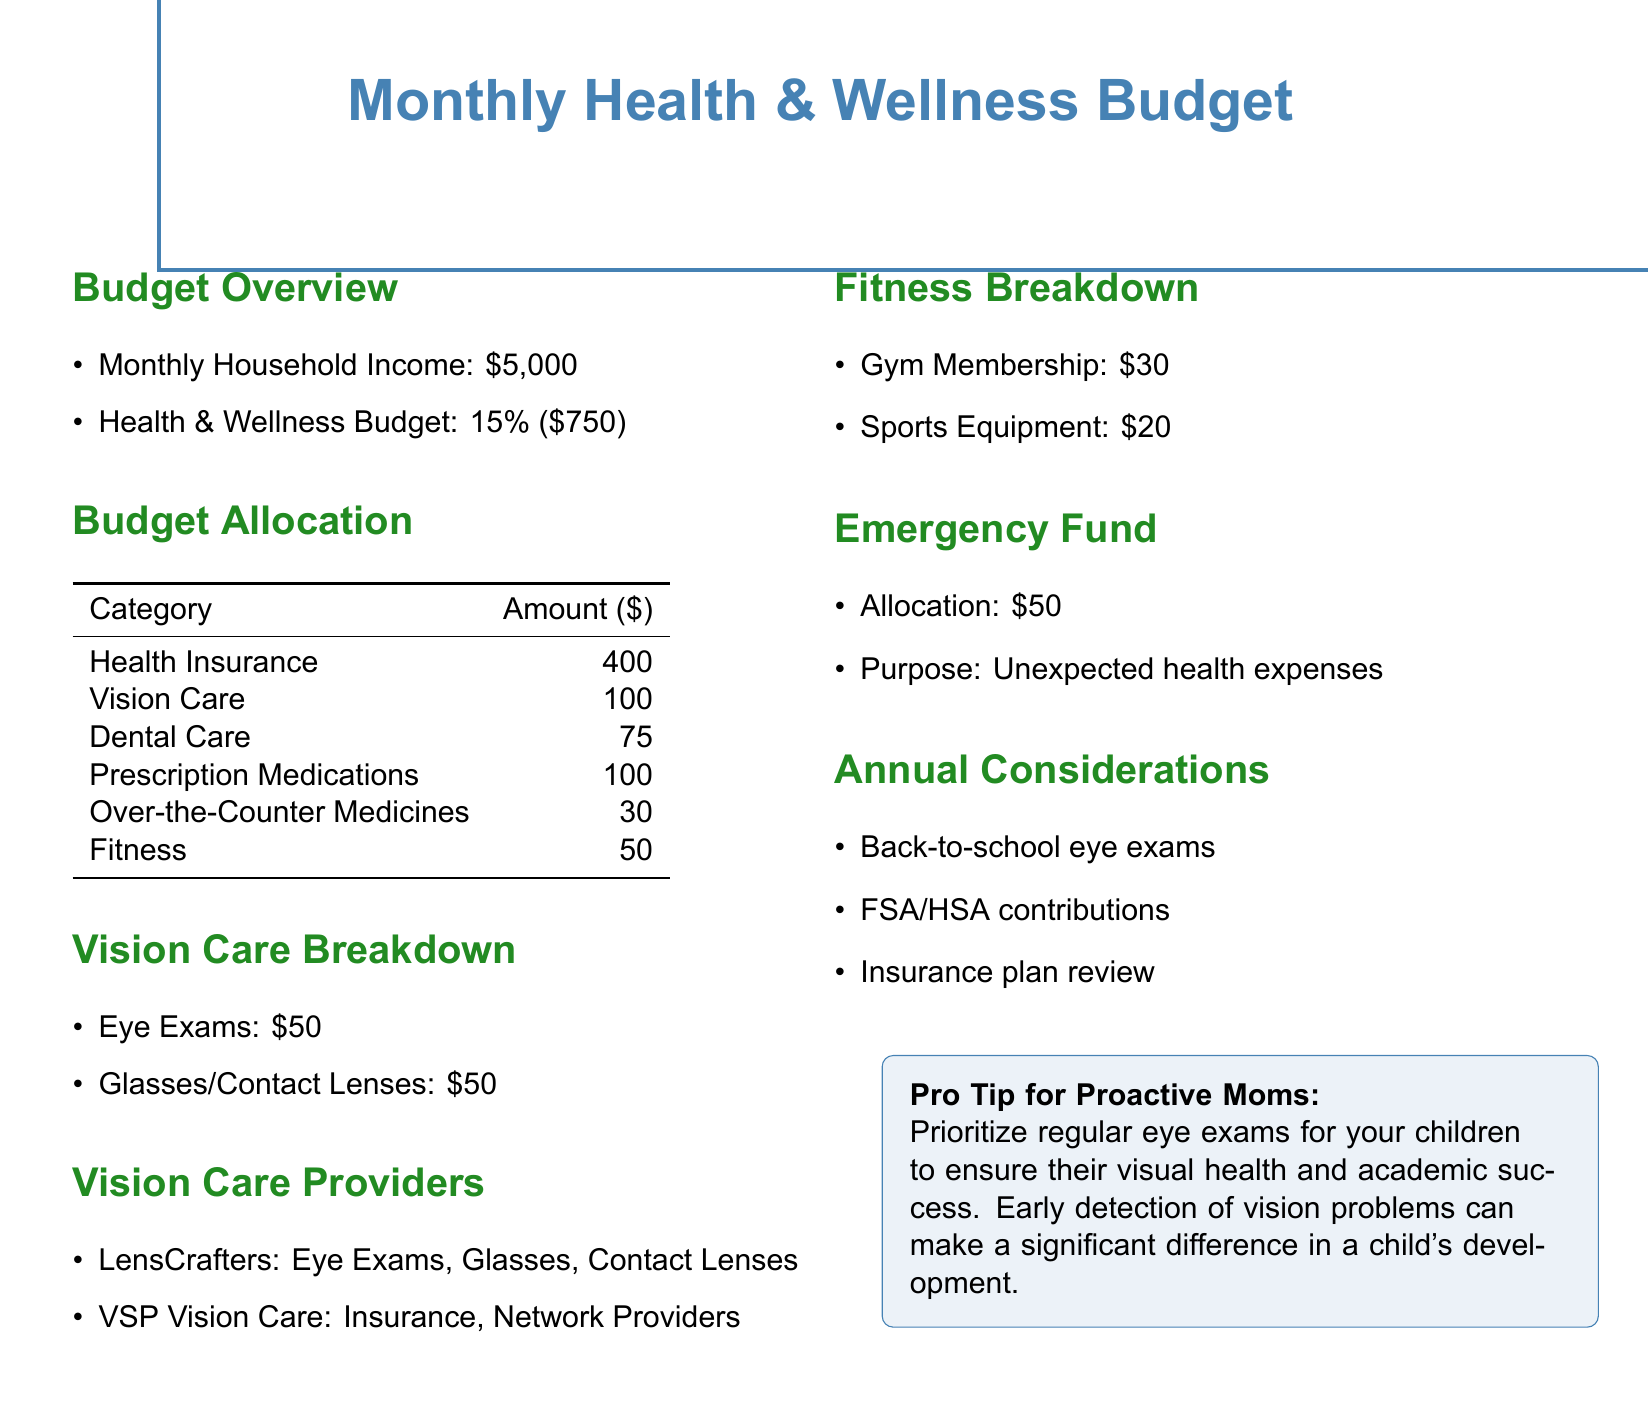What is the total health and wellness budget? The health and wellness budget is 15% of the monthly household income, calculated as $5000 * 0.15 = $750.
Answer: $750 How much is allocated for vision care? The allocation for vision care is stated directly in the budget table.
Answer: $100 What are the two components of vision care expenses? The vision care breakdown lists eye exams and glasses/contact lenses as the components.
Answer: Eye Exams, Glasses/Contact Lenses What is the budget for dental care? Dental care is listed in the budget allocation table with a specific amount.
Answer: $75 Which provider offers eye exams, glasses, and contact lenses? The vision care providers section lists LensCrafters as a provider of these services.
Answer: LensCrafters What is the emergency fund allocation? The document specifies the amount allocated for the emergency fund.
Answer: $50 What is the purpose of the emergency fund? The document states the purpose of the emergency fund relates to unexpected health expenses.
Answer: Unexpected health expenses What is the monthly cost for a gym membership? The fitness breakdown details the cost of a gym membership.
Answer: $30 Which vision care provider offers insurance and network providers? VSP Vision Care is identified in the document as a provider that offers these services.
Answer: VSP Vision Care 